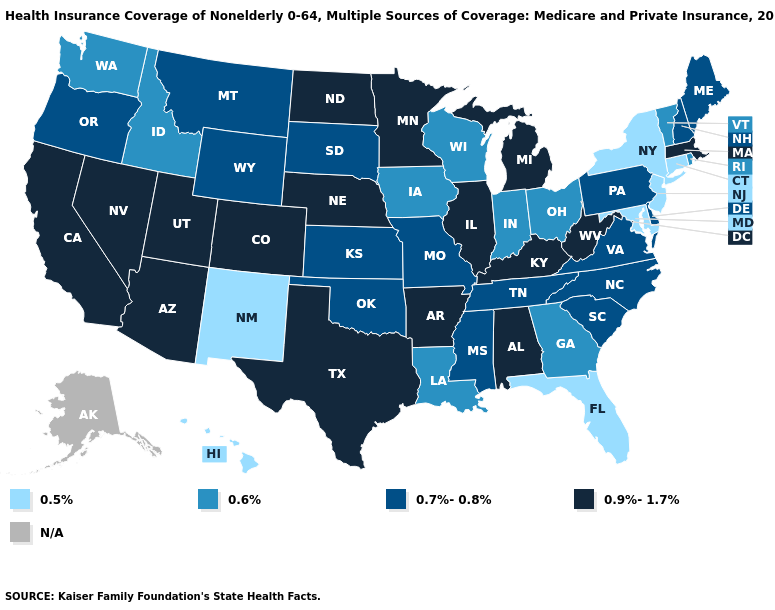What is the lowest value in the MidWest?
Be succinct. 0.6%. Which states have the highest value in the USA?
Short answer required. Alabama, Arizona, Arkansas, California, Colorado, Illinois, Kentucky, Massachusetts, Michigan, Minnesota, Nebraska, Nevada, North Dakota, Texas, Utah, West Virginia. What is the lowest value in the USA?
Answer briefly. 0.5%. What is the lowest value in states that border Maryland?
Short answer required. 0.7%-0.8%. Which states have the lowest value in the West?
Give a very brief answer. Hawaii, New Mexico. Which states have the lowest value in the USA?
Concise answer only. Connecticut, Florida, Hawaii, Maryland, New Jersey, New Mexico, New York. What is the lowest value in the MidWest?
Write a very short answer. 0.6%. Name the states that have a value in the range 0.7%-0.8%?
Short answer required. Delaware, Kansas, Maine, Mississippi, Missouri, Montana, New Hampshire, North Carolina, Oklahoma, Oregon, Pennsylvania, South Carolina, South Dakota, Tennessee, Virginia, Wyoming. Name the states that have a value in the range 0.6%?
Answer briefly. Georgia, Idaho, Indiana, Iowa, Louisiana, Ohio, Rhode Island, Vermont, Washington, Wisconsin. Which states hav the highest value in the South?
Write a very short answer. Alabama, Arkansas, Kentucky, Texas, West Virginia. Among the states that border Utah , which have the lowest value?
Short answer required. New Mexico. What is the lowest value in states that border Colorado?
Concise answer only. 0.5%. Does Minnesota have the highest value in the USA?
Answer briefly. Yes. Among the states that border Rhode Island , which have the lowest value?
Give a very brief answer. Connecticut. What is the highest value in the USA?
Concise answer only. 0.9%-1.7%. 